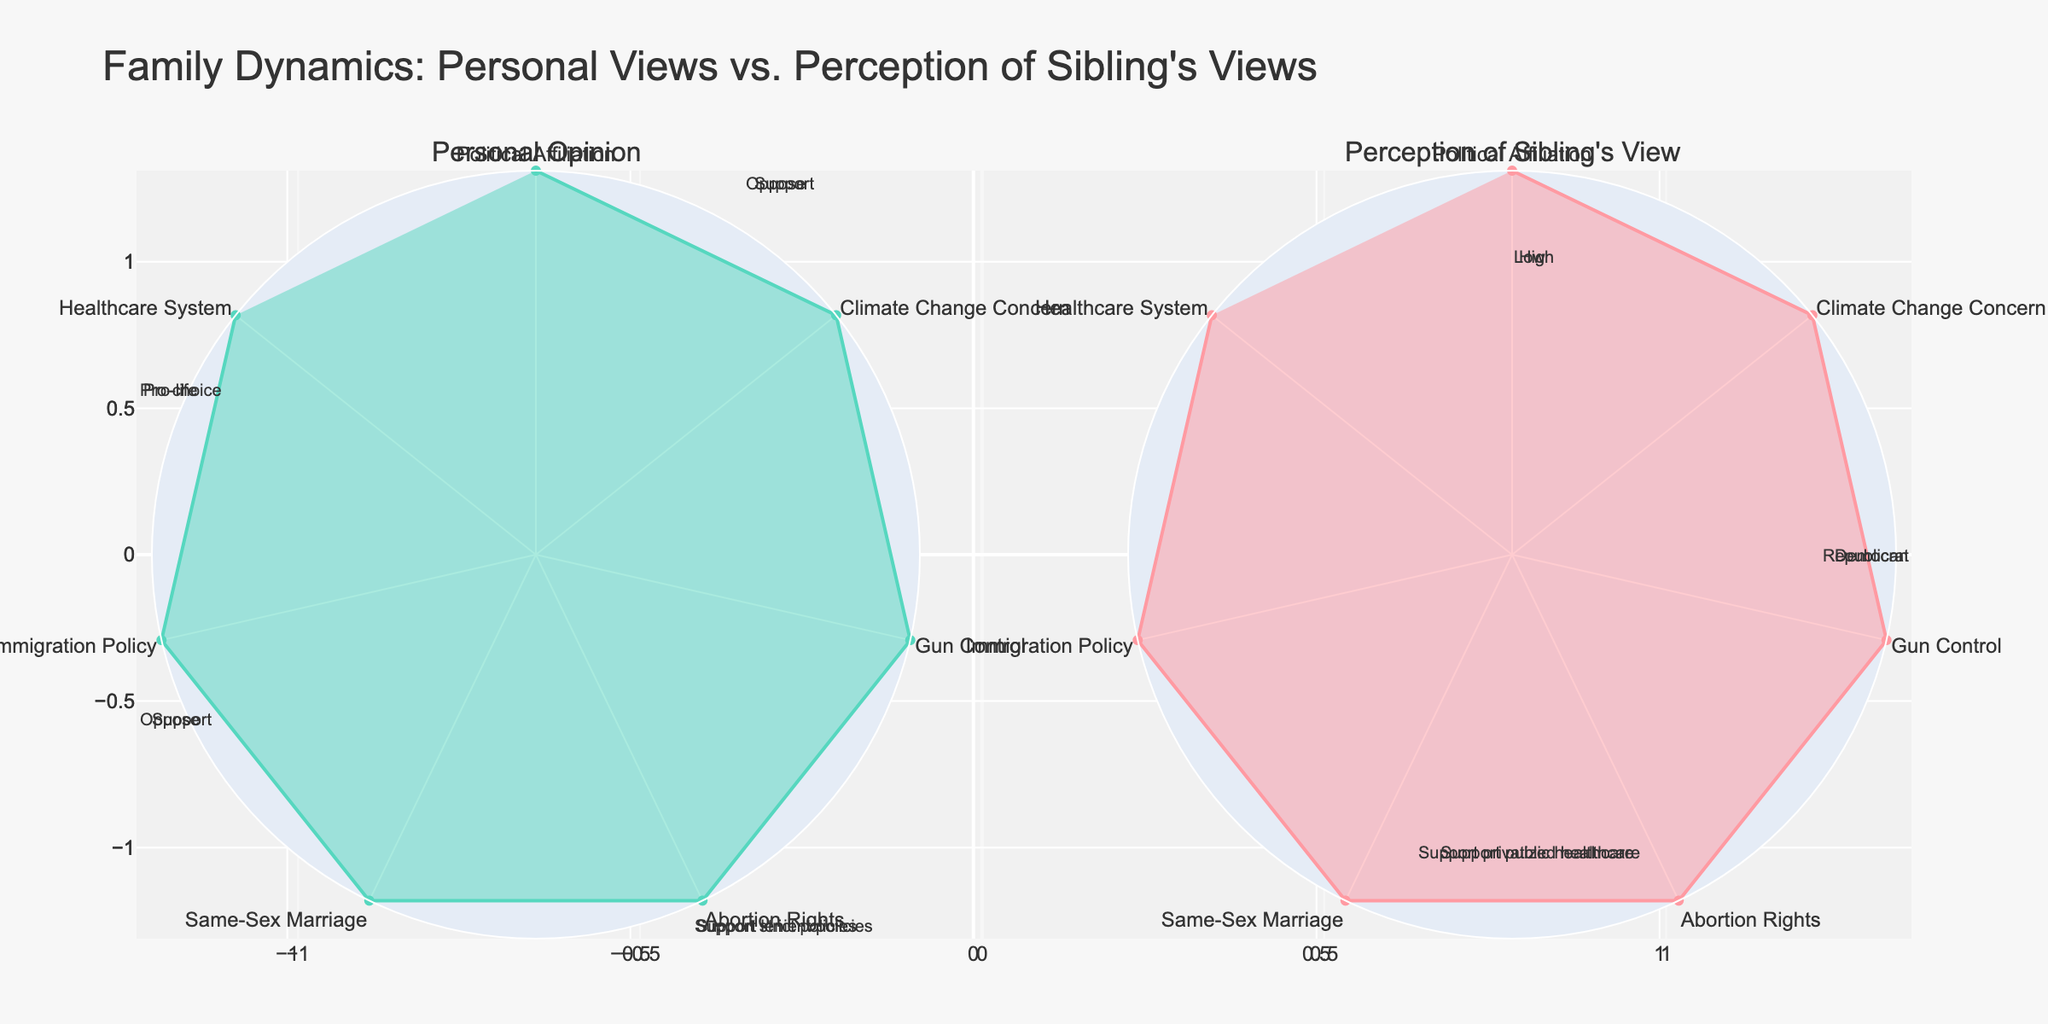What is the title of the figure? The title of the figure can be found at the top of the plot. It is prominently sized and centrally aligned.
Answer: Family Dynamics: Personal Views vs. Perception of Sibling's Views Which issues have differing views between personal opinion and perception of sibling's view? To answer this, compare each issue's personal opinion and sibling's view. Differences are noticeable if the descriptions don't match.
Answer: All issues have differing views How do the personal and sibling views compare on the issue of Gun Control? Look at the labels under the 'Gun Control' section on both subplots. The personal view label might show 'Support' while the sibling view label might show 'Oppose'.
Answer: Personal: Support, Sibling: Oppose Which side shows support for privatized healthcare? Check the Healthcare System section in both subplots. The sibling's view probably supports privatized healthcare as mentioned in the data.
Answer: Sibling's view In what issue does the personal view align with being 'Pro-choice'? Find the issue labeled 'Pro-choice' on the personal opinion subplot. The issue associated with this view is likely 'Abortion Rights'.
Answer: Abortion Rights How many total categories are compared in the figure? Count the number of issues or sections radiating from the center of one of the radar charts. Each issue is a category.
Answer: 7 In which issue is climate change concern addressed, and how do the views differ? Locate the 'Climate Change Concern' issue on both subplots. Personal opinion might show 'High', while the sibling's view could show 'Low'.
Answer: Personal: High, Sibling: Low What is the visual color difference between personal opinions and perceived sibling's views? Identify the colors filling the radar charts: personal opinions are likely in a shade of light blue or green, while sibling's views might be in a shade of light pink or red.
Answer: Personal: light blue/green, Sibling: light pink/red Which subplot represents the perception of the sibling's view? The subplot titles denote what each radar chart represents. The right subplot, with the title "Perception of Sibling's View," represents this data.
Answer: Right subplot Explain the views on immigration policy. Compare the descriptions for 'Immigration Policy' in both subplots. The personal view may say 'Support lenient policies,' while the sibling's view could say 'Support strict policies.'
Answer: Personal: lenient policies, Sibling: strict policies 